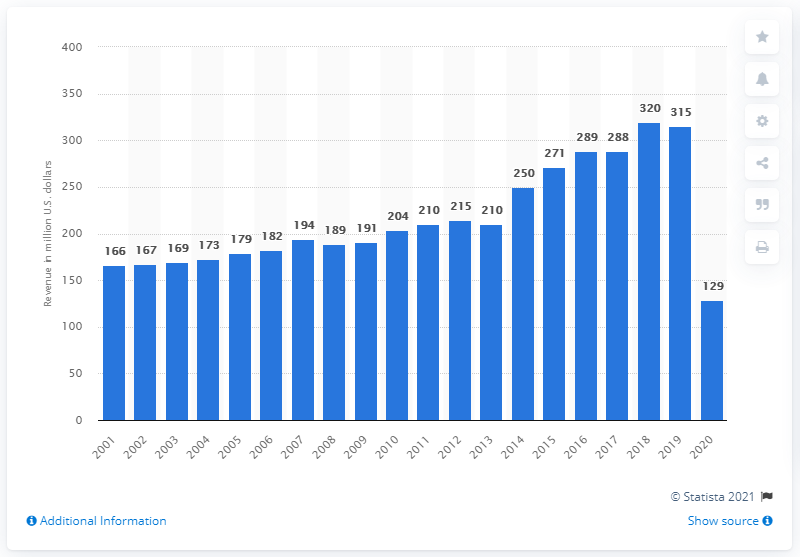Indicate a few pertinent items in this graphic. In 2020, the Seattle Mariners generated a revenue of 129 million US dollars. 